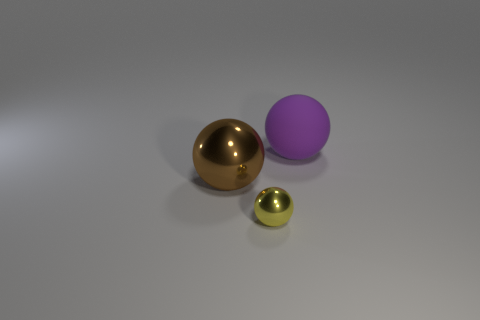Subtract all matte balls. How many balls are left? 2 Subtract all yellow balls. How many balls are left? 2 Subtract 1 balls. How many balls are left? 2 Subtract all gray cylinders. How many red spheres are left? 0 Subtract all big purple rubber things. Subtract all large matte things. How many objects are left? 1 Add 3 rubber spheres. How many rubber spheres are left? 4 Add 2 tiny yellow spheres. How many tiny yellow spheres exist? 3 Add 1 small yellow metallic blocks. How many objects exist? 4 Subtract 0 red cubes. How many objects are left? 3 Subtract all cyan spheres. Subtract all red cylinders. How many spheres are left? 3 